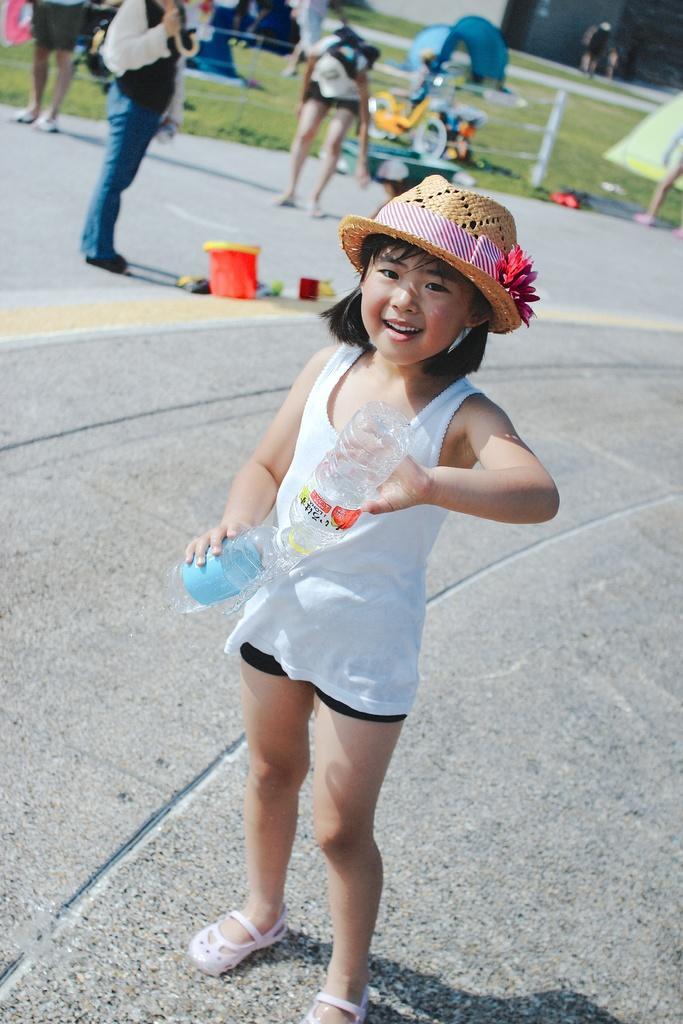Describe this image in one or two sentences. In this image we can see a kid standing and holding the bottles, behind the kid we can see a few people, there are some objects on the ground, also we can see the tents and fence. 